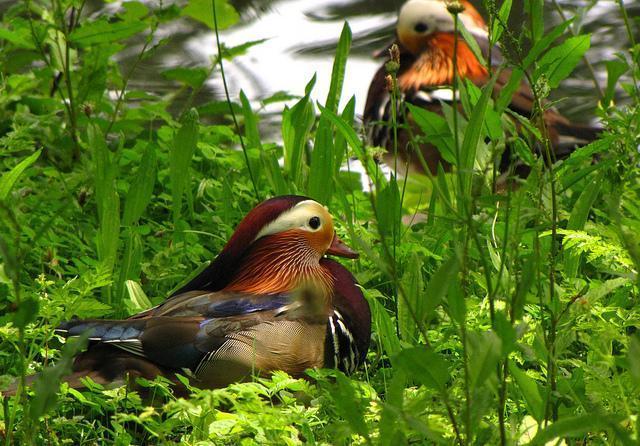How many birds are visible?
Give a very brief answer. 2. How many birds are there?
Give a very brief answer. 2. 